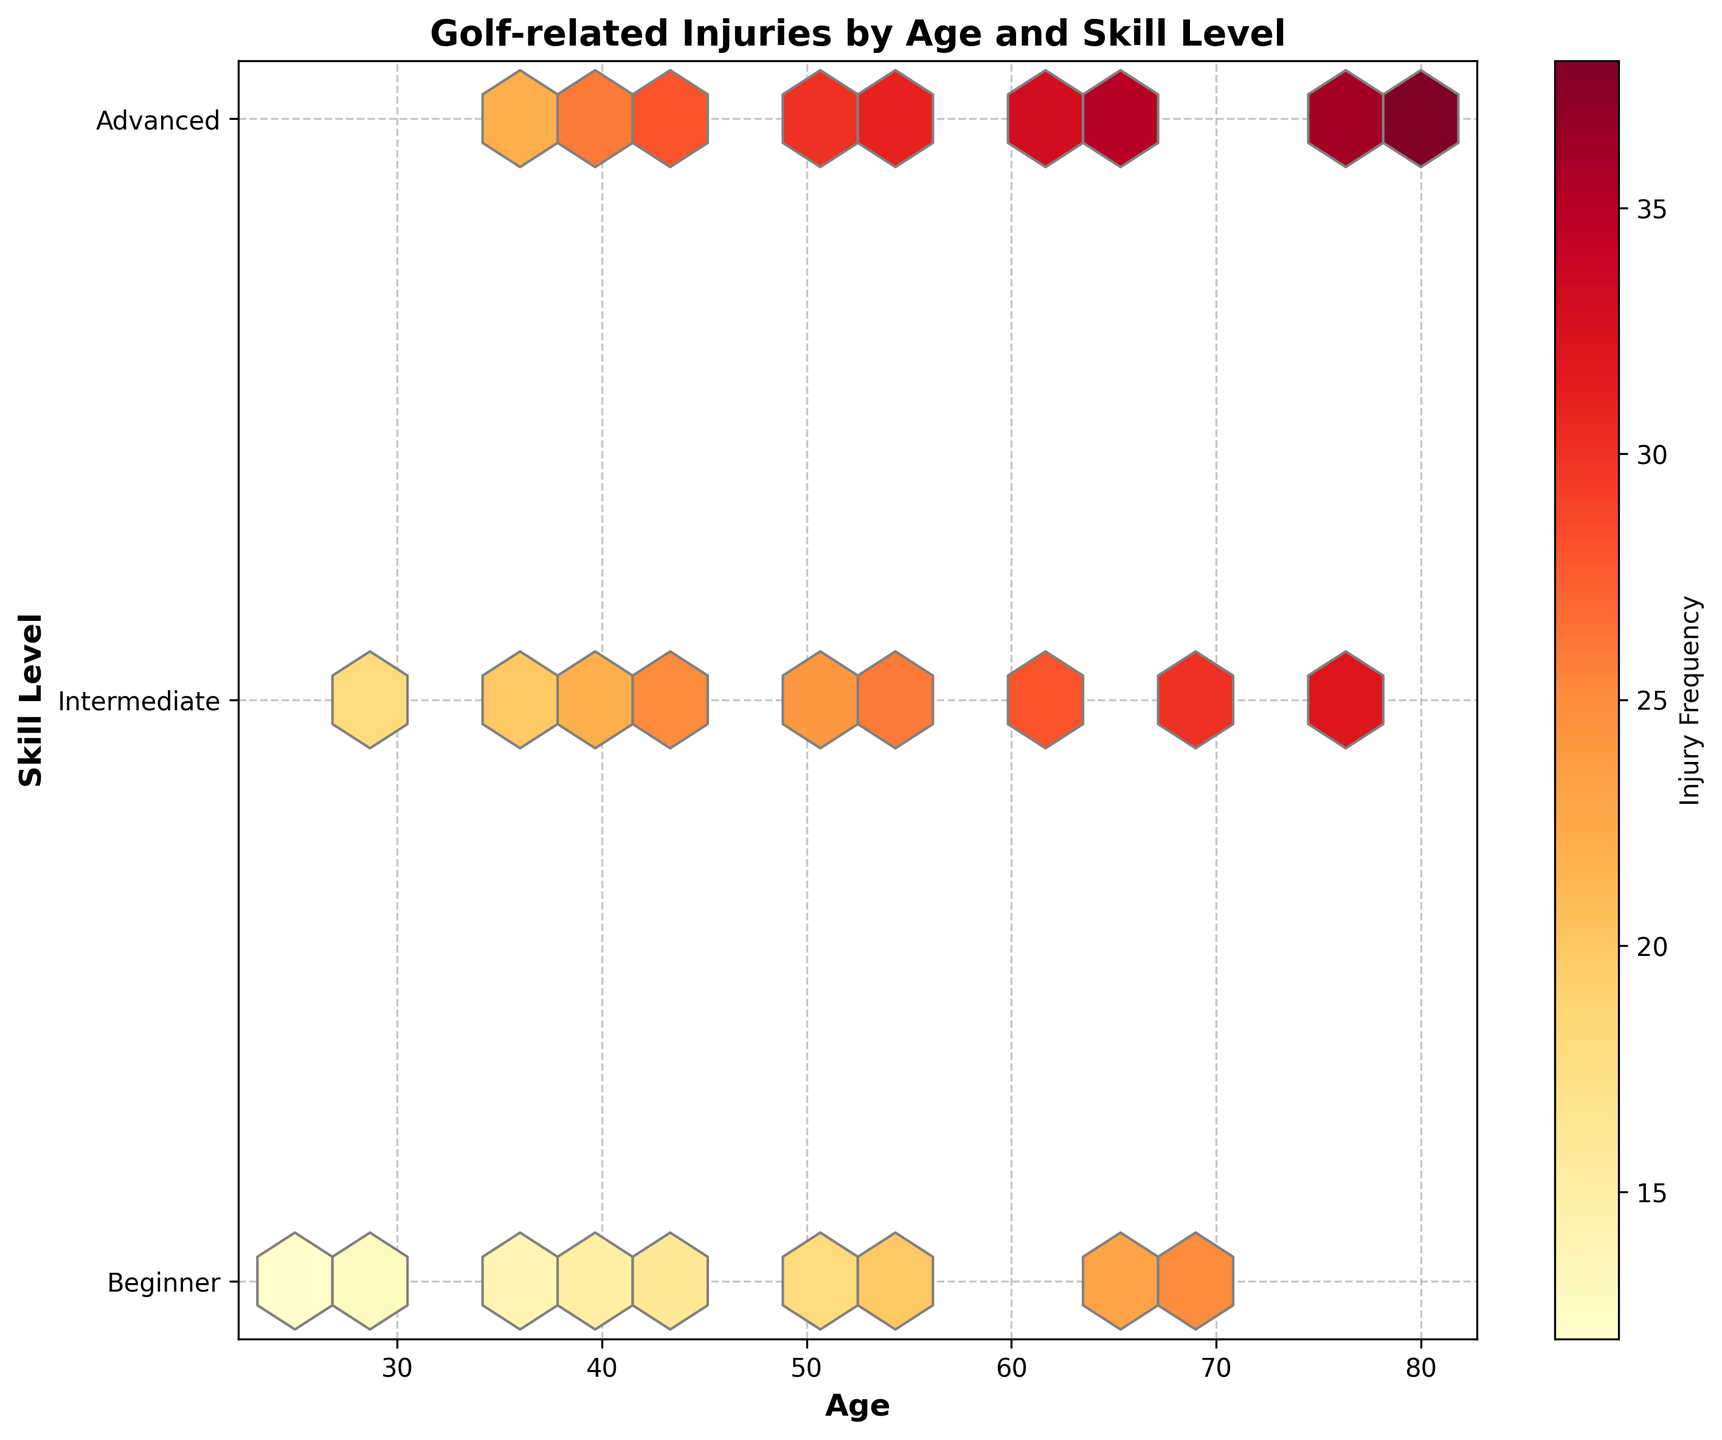What's the title of the plot? The title of the plot is located at the top center of the figure, indicating what the plot is about.
Answer: Golf-related Injuries by Age and Skill Level What are the labels for the x-axis and y-axis? The x-axis label is at the bottom of the plot, while the y-axis label is to the left of the plot. These labels describe what data the respective axes represent.
Answer: Age (x-axis) and Skill Level (y-axis) Which skill level has the highest reported injury frequency for ages 40 and 45? Looking at the bins along the x-axis at ages 40 and 45, trace upwards to the y-axis to check the color indicating injury frequency at each skill level.
Answer: Advanced What age group shows the highest frequency of golf-related injuries for beginners? Find the highest frequency value represented by the darkest color in the hexbin plot for the 'Beginner' skill level along the y-axis, then trace it back to the age on the x-axis.
Answer: Ages around 70-75 How does the injury frequency trend with age for intermediate players? Observe the change in color gradient for the intermediate skill level (y-axis value 2) across different age groups on the x-axis.
Answer: It increases with age Is there a noticeable difference in injury frequency between advanced and intermediate players at age 50? Compare the color of the bin for advanced players (y-axis value 3) to that of the intermediate players (y-axis value 2), both at age 50 on the x-axis.
Answer: Yes, advanced players have a higher frequency Which skill level and age combination has the lowest frequency of injuries? Look for the lightest color bins in the plot and identify their position on the x-axis (age) and y-axis (skill level)
Answer: Beginner at age 25 Among all skill levels, who experiences the highest frequency of injuries at age 60? Track the age 60 position on the x-axis, then move vertically to scan the bins at different skill levels and compare their colors to determine the highest frequency.
Answer: Advanced Are there any age groups where beginners have higher injury frequencies compared to advanced players? Compare the color intensity of bins for 'Beginner' (y-axis value 1) and 'Advanced' (y-axis value 3) across various ages on the x-axis.
Answer: No 